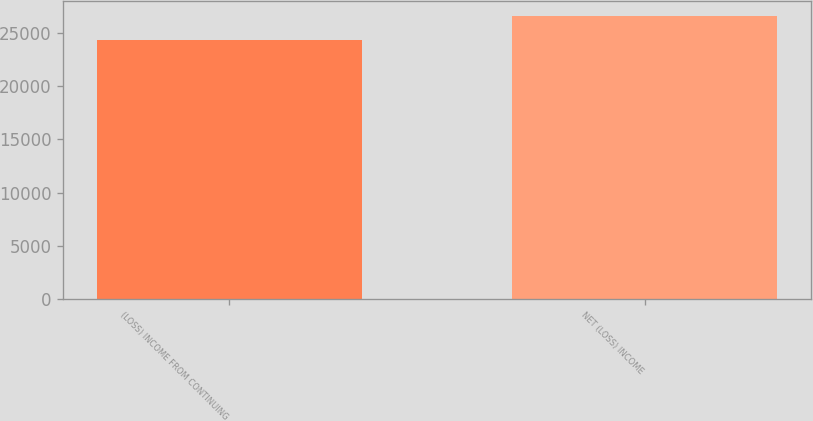Convert chart to OTSL. <chart><loc_0><loc_0><loc_500><loc_500><bar_chart><fcel>(LOSS) INCOME FROM CONTINUING<fcel>NET (LOSS) INCOME<nl><fcel>24362<fcel>26684.2<nl></chart> 